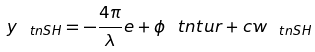<formula> <loc_0><loc_0><loc_500><loc_500>y _ { _ { \ } t n { S H } } = - \frac { 4 \pi } { \lambda } e + \phi _ { \ } t n { t u r } + c w _ { _ { \ } t n { S H } }</formula> 